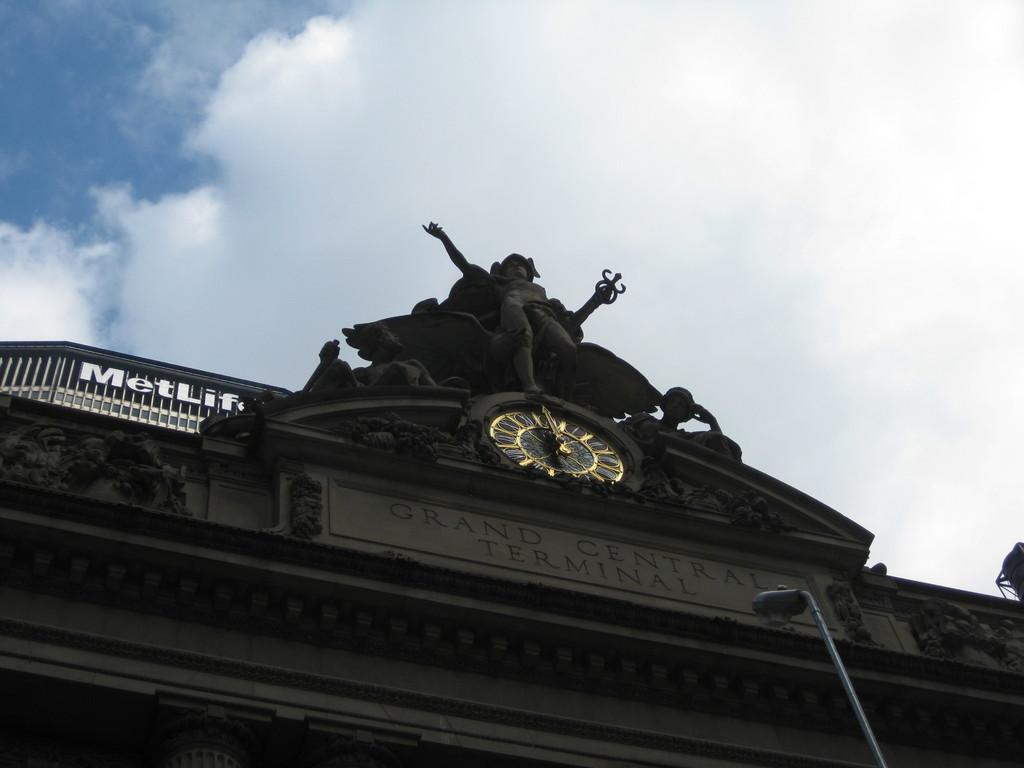<image>
Write a terse but informative summary of the picture. A building behind the clock has Metlife at the top. 